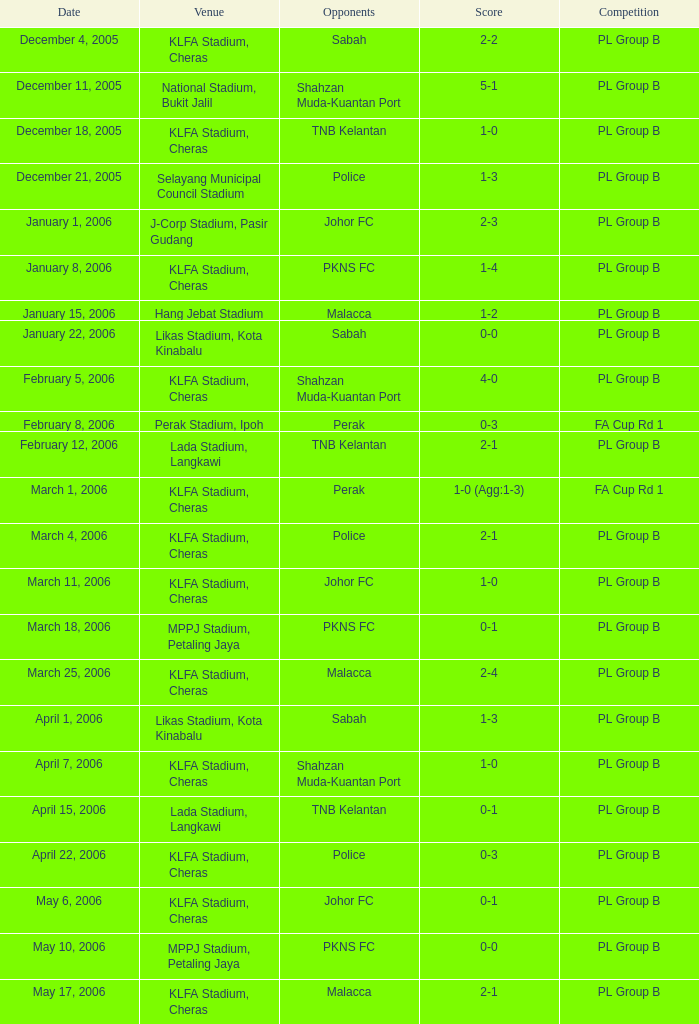Which Competition has Opponents of pkns fc, and a Score of 0-0? PL Group B. 